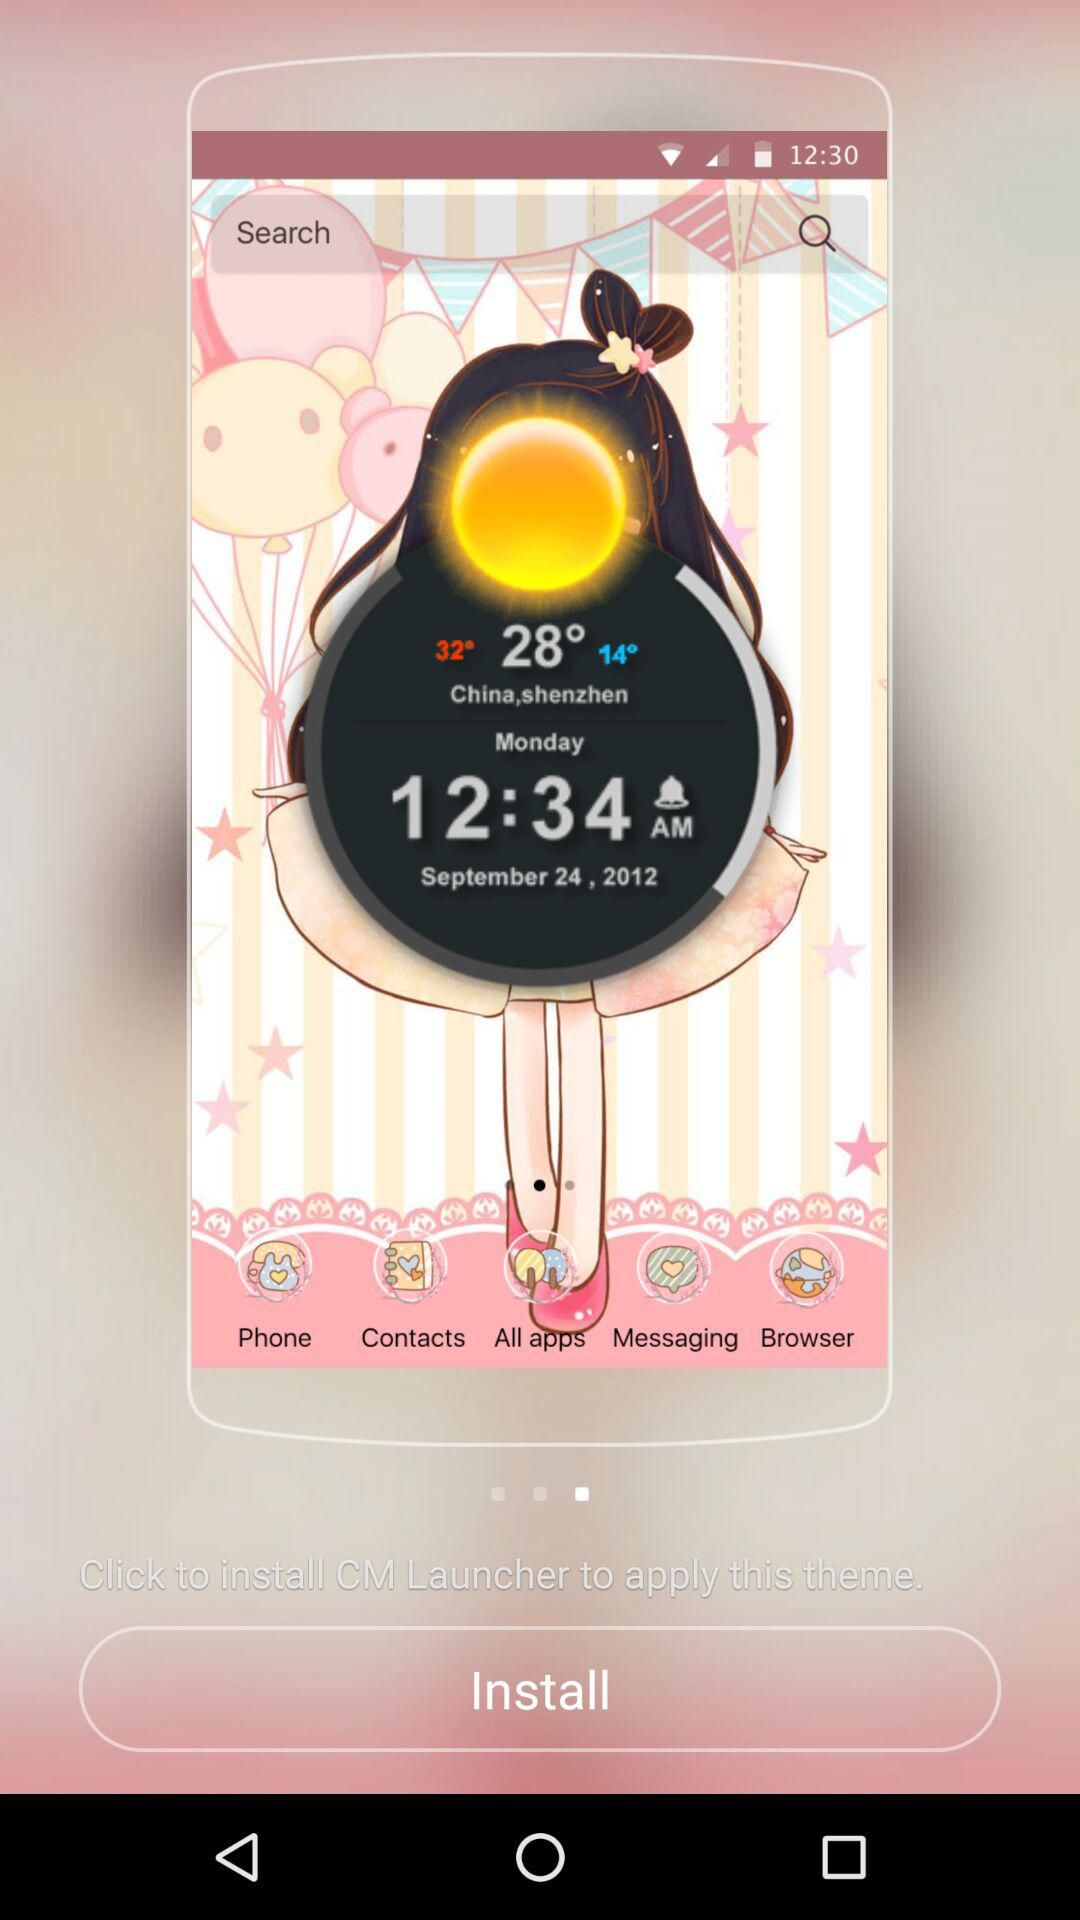What is the given location? The given location is Shenzhen, China. 